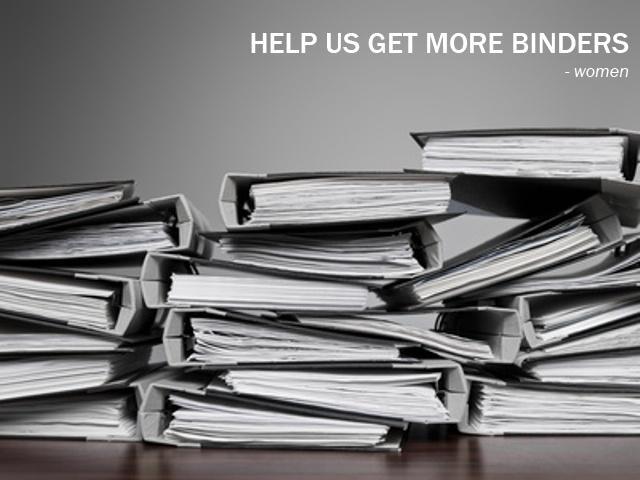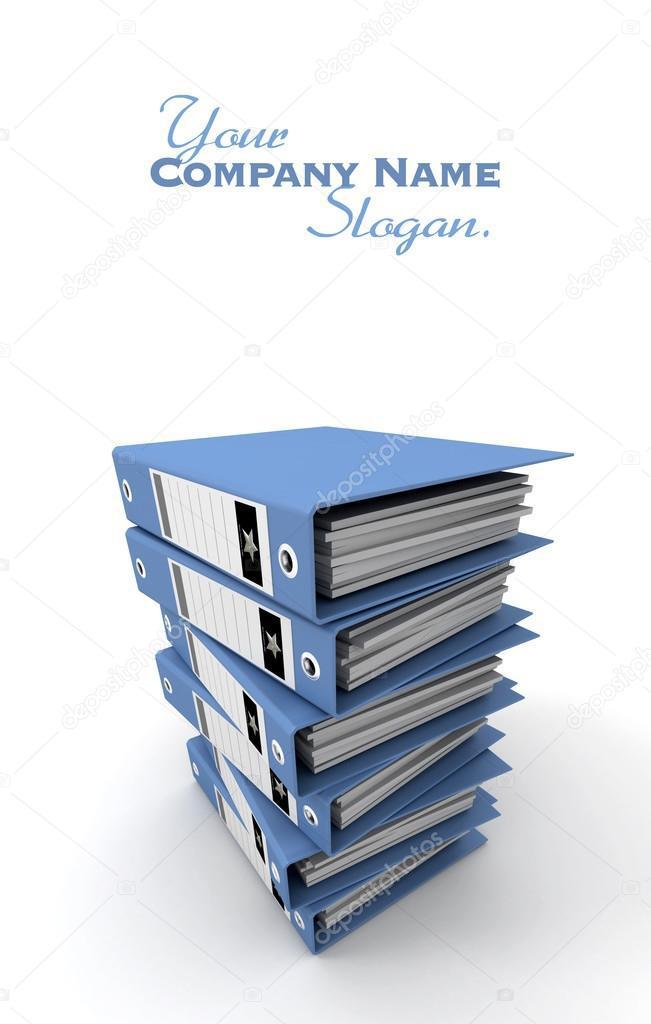The first image is the image on the left, the second image is the image on the right. Considering the images on both sides, is "At least one image shows binders stacked alternately front-to-back, with no more than seven total binders in the image." valid? Answer yes or no. No. 